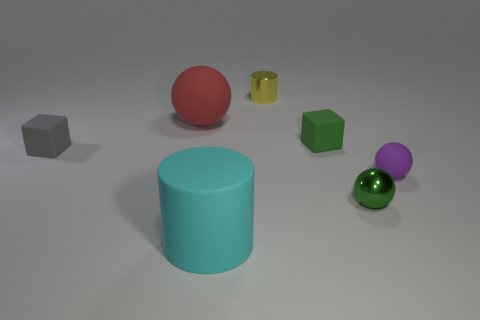What is the material of the big cyan thing in front of the small green metal object?
Your answer should be compact. Rubber. Do the green metal object and the green matte cube have the same size?
Your answer should be very brief. Yes. What color is the tiny matte thing that is in front of the tiny green rubber thing and to the right of the tiny yellow metallic cylinder?
Provide a short and direct response. Purple. The large cyan object that is made of the same material as the large red sphere is what shape?
Give a very brief answer. Cylinder. How many shiny things are both behind the green matte object and in front of the yellow metal cylinder?
Your answer should be very brief. 0. Are there any big objects behind the matte cylinder?
Your answer should be compact. Yes. There is a green object behind the tiny metal sphere; is its shape the same as the rubber object that is in front of the purple thing?
Offer a very short reply. No. How many things are blue shiny blocks or shiny objects that are in front of the tiny yellow thing?
Ensure brevity in your answer.  1. How many other objects are there of the same shape as the purple object?
Provide a succinct answer. 2. Are the cube right of the tiny gray matte thing and the gray cube made of the same material?
Give a very brief answer. Yes. 